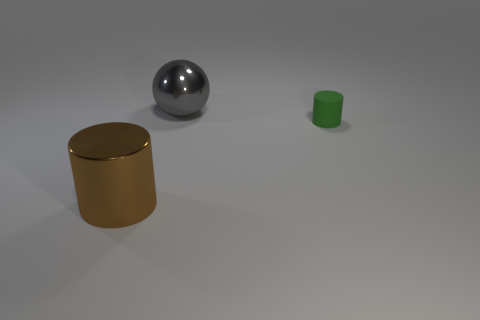Are there any other small green matte things of the same shape as the small green rubber object? Upon careful inspection of the image, there is only one small green object with a matte finish. It is cylindrical in shape and no other items of the same shape and color are present. 